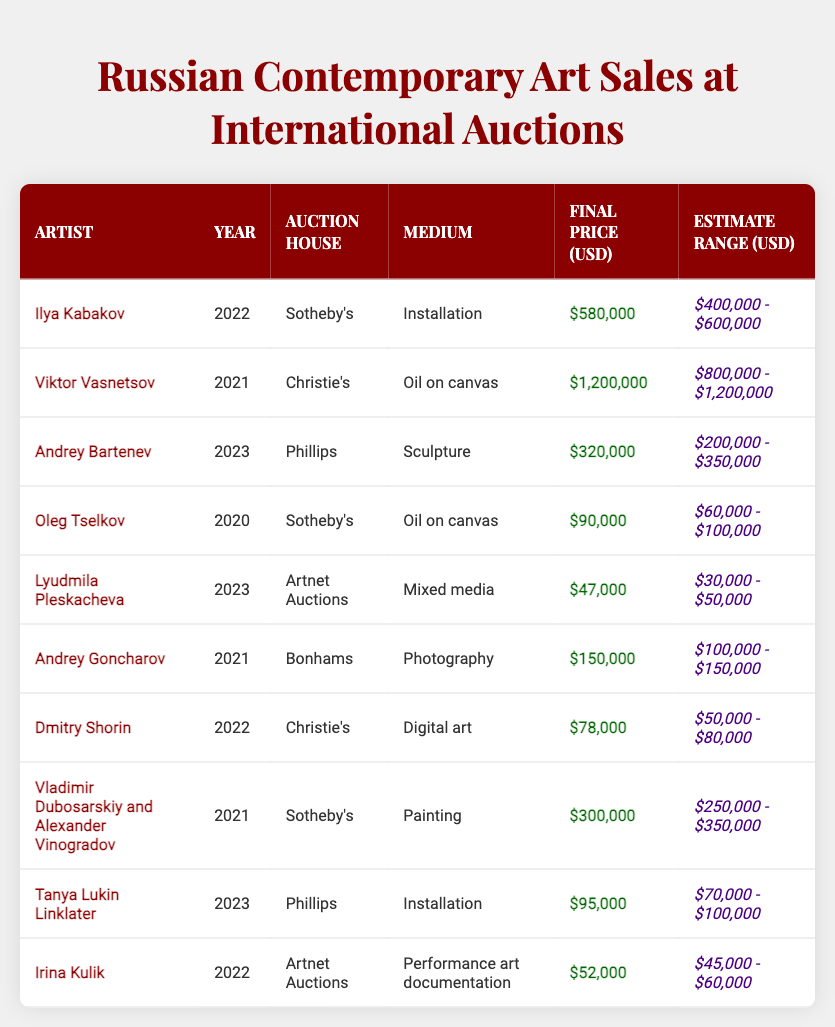What is the highest final price for a Russian contemporary artwork sold at auction? The highest final price listed in the table is $1,200,000, which is for the artwork by Viktor Vasnetsov in 2021.
Answer: $1,200,000 Which auction house sold the most expensive artwork by a Russian artist? The artwork by Viktor Vasnetsov was sold by Christie's and had the highest final price in the data, which indicates Christie's sold the most expensive Russian contemporary artwork.
Answer: Christie's What is the average final price of artworks sold in 2023? The final prices for 2023 artworks are $320,000 (Andrey Bartenev), $47,000 (Lyudmila Pleskacheva), and $95,000 (Tanya Lukin Linklater). Summing these gives $462,000, and dividing by 3 gives an average final price of $154,000.
Answer: $154,000 Did any artwork sell for above its estimate range? Yes, the artwork by Ilya Kabakov sold for $580,000, while its estimate range was $400,000 - $600,000 which means it sold exactly at the high estimate, and the artwork by Viktor Vasnetsov sold for $1,200,000 which is above its estimate range of $800,000 - $1,200,000.
Answer: Yes How many artworks sold for less than $100,000? The artworks by Oleg Tselkov ($90,000), Lyudmila Pleskacheva ($47,000), Dmitry Shorin ($78,000), and Irina Kulik ($52,000) sold for less than $100,000. Counting these gives a total of four artworks.
Answer: 4 What was the final price of the artwork by Dmitry Shorin? The final price of Dmitry Shorin's artwork sold at Christie's in 2022 was $78,000.
Answer: $78,000 Which artist's work had the lowest final sale price? The artwork by Lyudmila Pleskacheva had the lowest final price of $47,000 among all the listed artworks.
Answer: Lyudmila Pleskacheva How many different auction houses sold artworks by Russian artists according to the data? The auction houses listed are Sotheby's, Christie's, Phillips, Bonhams, and Artnet Auctions. This count shows that there are five different auction houses in total.
Answer: 5 If we combine the final prices of artworks sold at Christie's, what would their total be? The total for artworks sold at Christie's is $1,200,000 (Viktor Vasnetsov) + $78,000 (Dmitry Shorin) = $1,278,000.
Answer: $1,278,000 What percentage of the artworks sold had final prices above $100,000? There are 10 artworks listed; 6 of these sold for above $100,000 ($1,200,000, $580,000, $320,000, $150,000, $300,000, and $95,000). To find the percentage, we calculate (6/10) * 100 = 60%.
Answer: 60% 